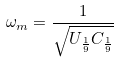Convert formula to latex. <formula><loc_0><loc_0><loc_500><loc_500>\omega _ { m } = \frac { 1 } { \sqrt { U _ { \frac { 1 } { 9 } } C _ { \frac { 1 } { 9 } } } }</formula> 